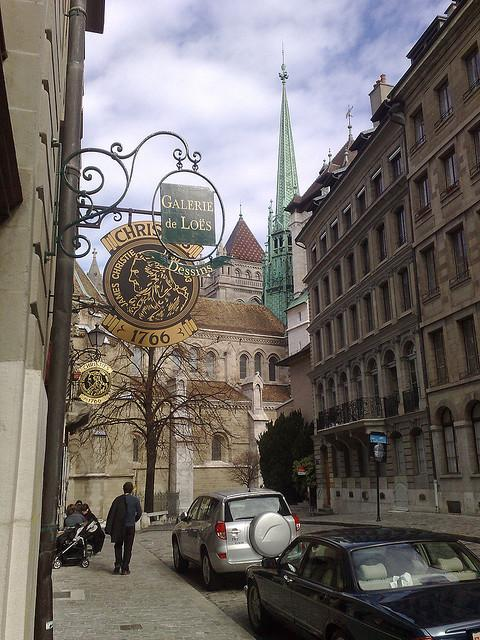Where is there most likely to be a baby at in this picture?

Choices:
A) stroller
B) building
C) car
D) tree stroller 